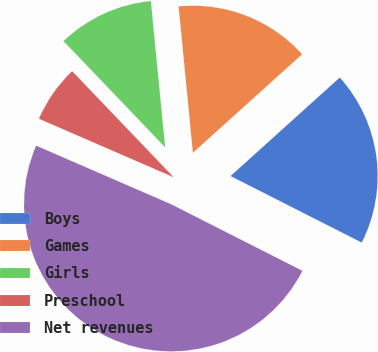Convert chart to OTSL. <chart><loc_0><loc_0><loc_500><loc_500><pie_chart><fcel>Boys<fcel>Games<fcel>Girls<fcel>Preschool<fcel>Net revenues<nl><fcel>19.15%<fcel>14.87%<fcel>10.6%<fcel>6.33%<fcel>49.05%<nl></chart> 